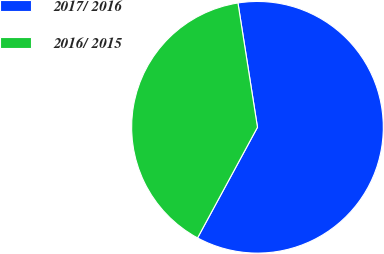Convert chart. <chart><loc_0><loc_0><loc_500><loc_500><pie_chart><fcel>2017/ 2016<fcel>2016/ 2015<nl><fcel>60.38%<fcel>39.62%<nl></chart> 